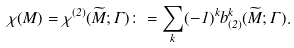<formula> <loc_0><loc_0><loc_500><loc_500>\chi ( M ) = \chi ^ { ( 2 ) } ( \widetilde { M } ; \Gamma ) \colon = \sum _ { k } ( - 1 ) ^ { k } b ^ { k } _ { ( 2 ) } ( \widetilde { M } ; \Gamma ) .</formula> 